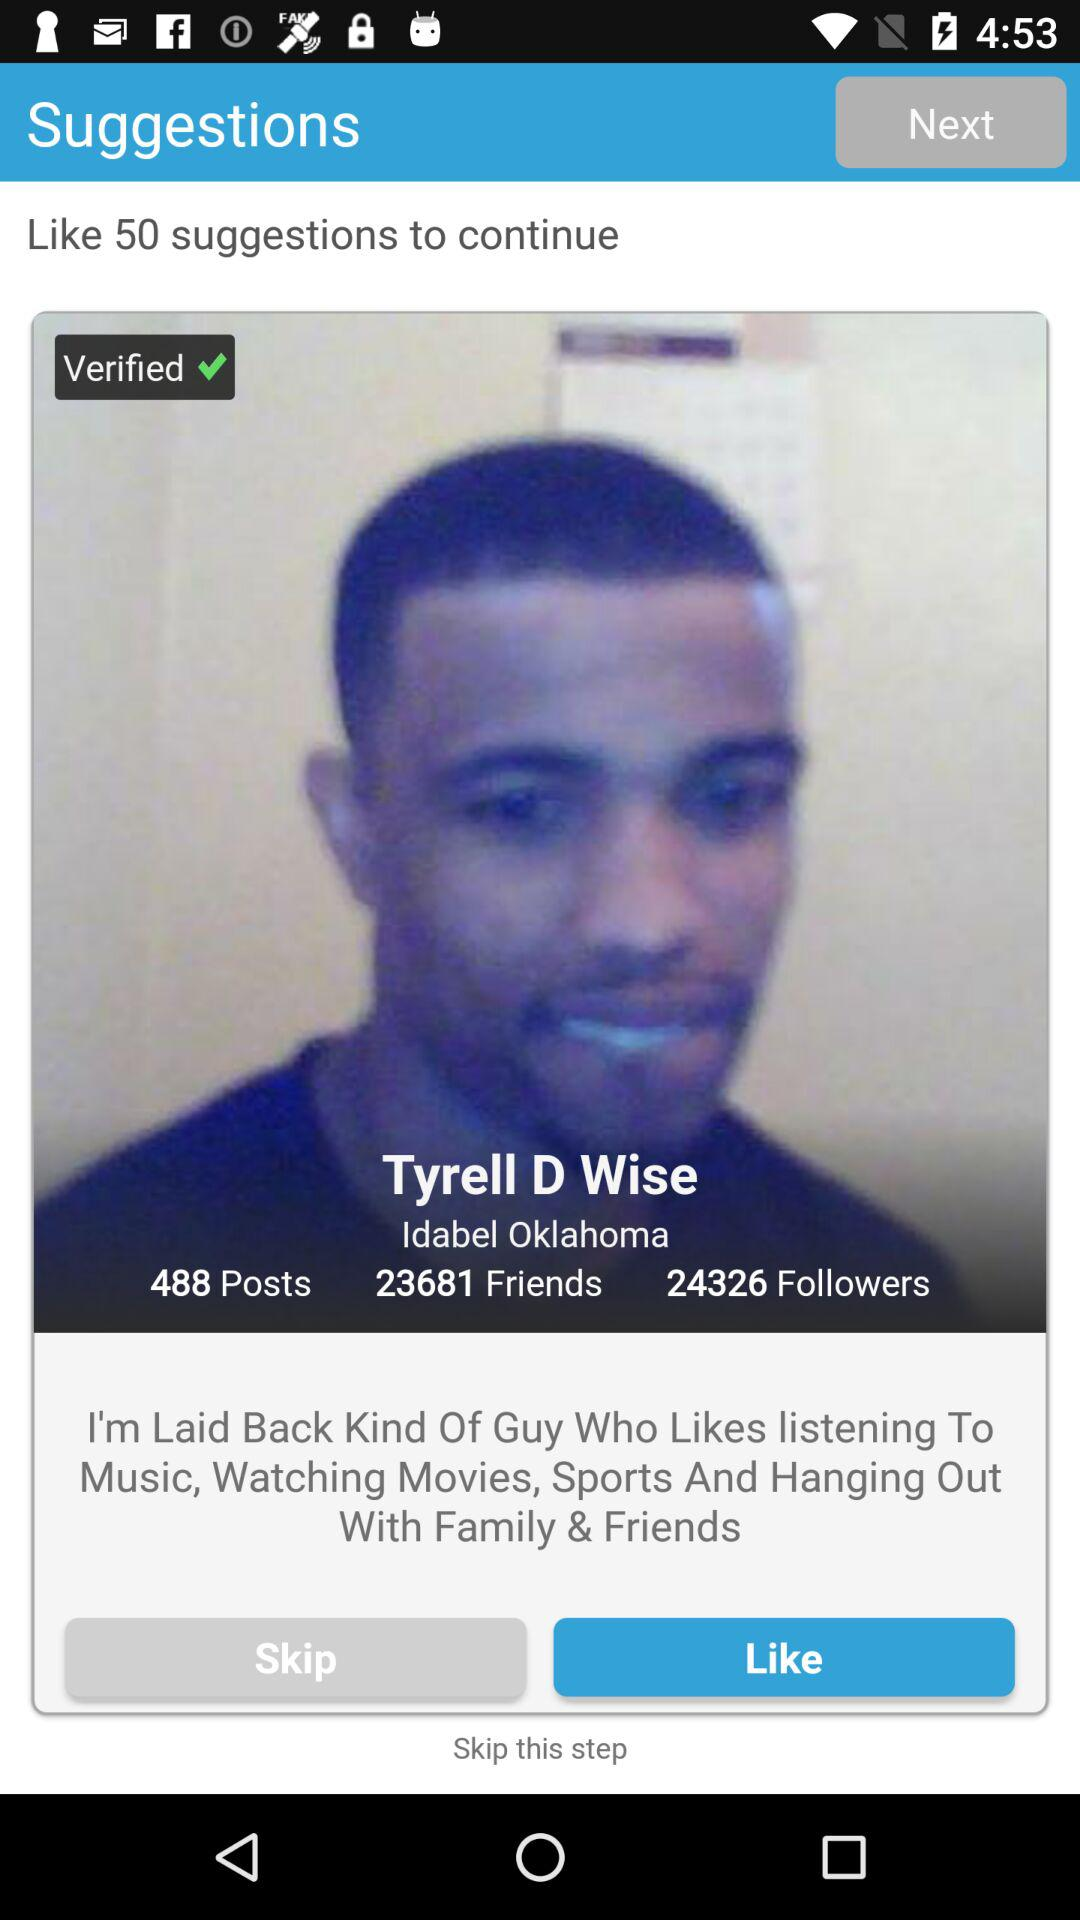How many people are following Tyrell D Wise? Tyrell D wise has 24326 followers. 